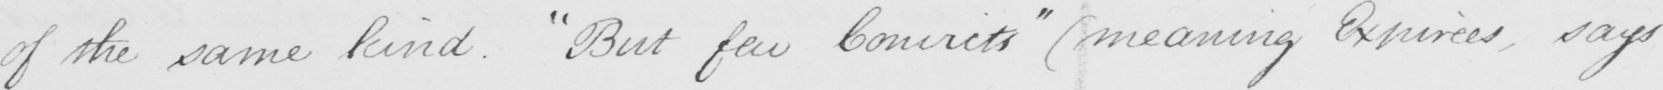Transcribe the text shown in this historical manuscript line. of the same kind .  " But few Convicts "   ( meaning Expirees , says 